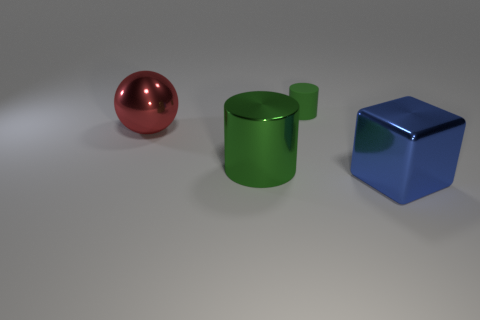Can you tell me what the lighting in the scene suggests about the location of the light source? The shadows cast by the objects are relatively soft and oriented to the bottom right of the image, which suggests that the light source is coming from the upper left side. The shadows also hint that the light source is quite diffused, possibly due to a larger light-emitting area or the presence of a diffusing material. 